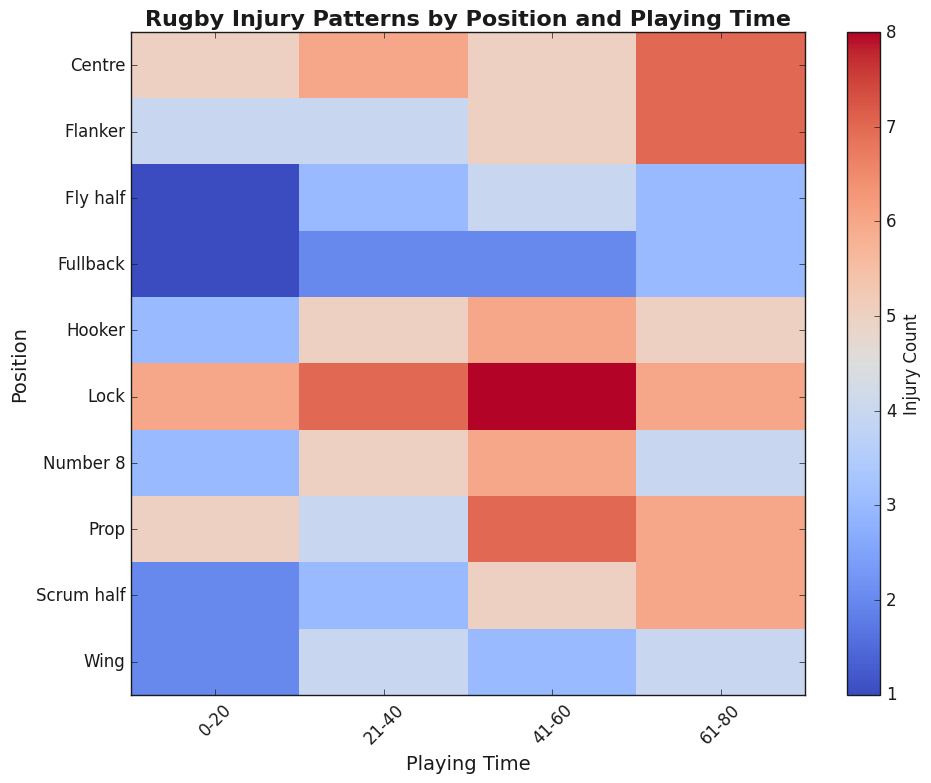Which position has the highest injury count in the 41-60 playing time interval? By examining the heatmap, the position with the darkest color in the 41-60 playing time interval has the highest injury count. The darkest color in this interval corresponds to the Lock position.
Answer: Lock What is the total injury count for the Flanker position across all playing time intervals? Summing the values for the Flanker position: 4 (0-20) + 4 (21-40) + 5 (41-60) + 7 (61-80) = 20.
Answer: 20 Between the Prop and the Fullback positions, which one has a higher injury count in the 21-40 playing time interval? By comparing the heatmap colors for the Prop and Fullback positions in the 21-40 interval, the Prop has a count of 4, while the Fullback has a count of 2. Therefore, the Prop position has a higher count.
Answer: Prop In which playing time interval does the Hooker position experience the most injuries? By comparing the colors across the intervals for the Hooker position, the 41-60 interval has the darkest color, indicating the highest injury count with a value of 6.
Answer: 41-60 What is the difference in injury count between the Wing and the Fly half positions in the 61-80 playing time interval? The injury count for Wing in the 61-80 interval is 4, and for Fly half, it is 3. The difference is calculated as 4 - 3 = 1.
Answer: 1 What is the average injury count for the Centre position across all playing time intervals? To find the average, sum the injury counts for the Centre position (5 + 6 + 5 + 7 = 23) and divide by the number of intervals (4). The average is 23 / 4 = 5.75.
Answer: 5.75 Which position has the least injury count in any playing time interval, and what is the count? By locating the lightest color on the heatmap, the Fly half position in the 0-20 interval has the least injury count with a value of 1.
Answer: Fly half, 1 How does the injury count for the Number 8 position in the 61-80 interval compare to that of the Lock position in the same interval? Observing the colors for Number 8 and Lock in the 61-80 interval, both show a similar shade. However, the precise counts are: Number 8 has 4 injuries, and Lock has 6 injuries. The Lock position has a higher count.
Answer: Lock has 2 more injuries 